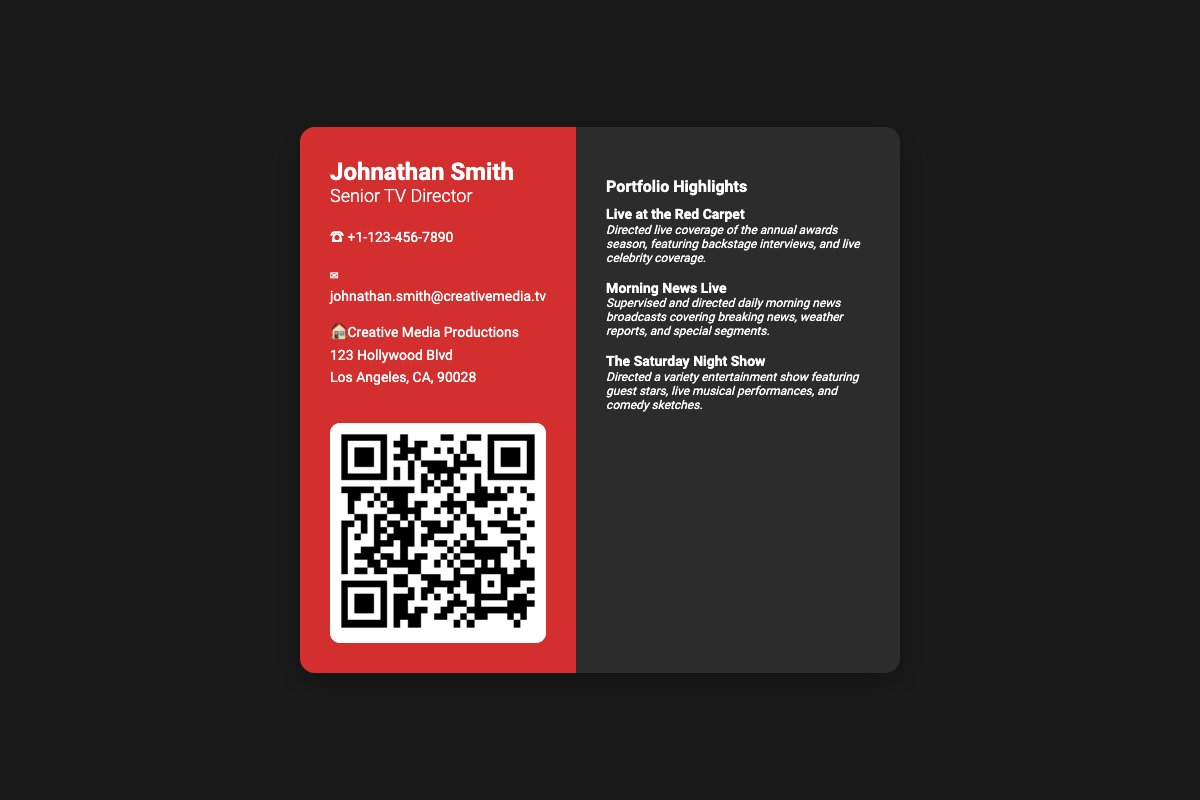What is the name on the business card? The name on the business card is prominently displayed at the top of the left side.
Answer: Johnathan Smith What is the title of Johnathan Smith? The title appears directly beneath the name, indicating his role.
Answer: Senior TV Director What is Johnathan's phone number? The phone number is listed in the contact information section of the document.
Answer: +1-123-456-7890 What company does Johnathan work for? The company name is mentioned along with the office address on the left side.
Answer: Creative Media Productions What is the URL linked to the QR code? The QR code directs to an online portfolio, which is mentioned in the QR code image link.
Answer: https://johnathansmithportfolio.com How many portfolio highlights are listed? The number of projects in the portfolio highlights section indicates the extent of John's experience.
Answer: 3 What is one live project directed by Johnathan? The portfolio highlights section lists specific projects he directed, showing his experience.
Answer: Live at the Red Carpet What city is Johnathan's office located in? The office address section specifies the city of the office location.
Answer: Los Angeles What kind of technology is integrated into the business card? The business card includes a feature that utilizes modern technology for quick access to information.
Answer: QR Code 